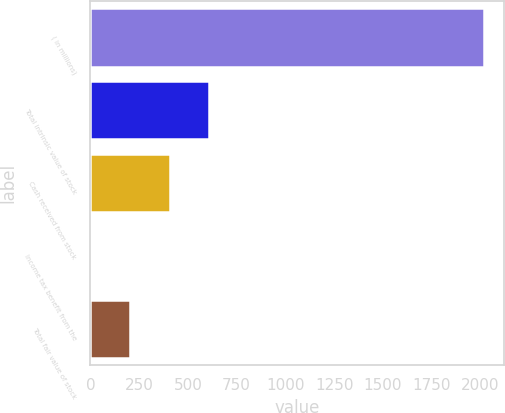Convert chart. <chart><loc_0><loc_0><loc_500><loc_500><bar_chart><fcel>( in millions)<fcel>Total intrinsic value of stock<fcel>Cash received from stock<fcel>Income tax benefit from the<fcel>Total fair value of stock<nl><fcel>2018<fcel>608.2<fcel>406.8<fcel>4<fcel>205.4<nl></chart> 